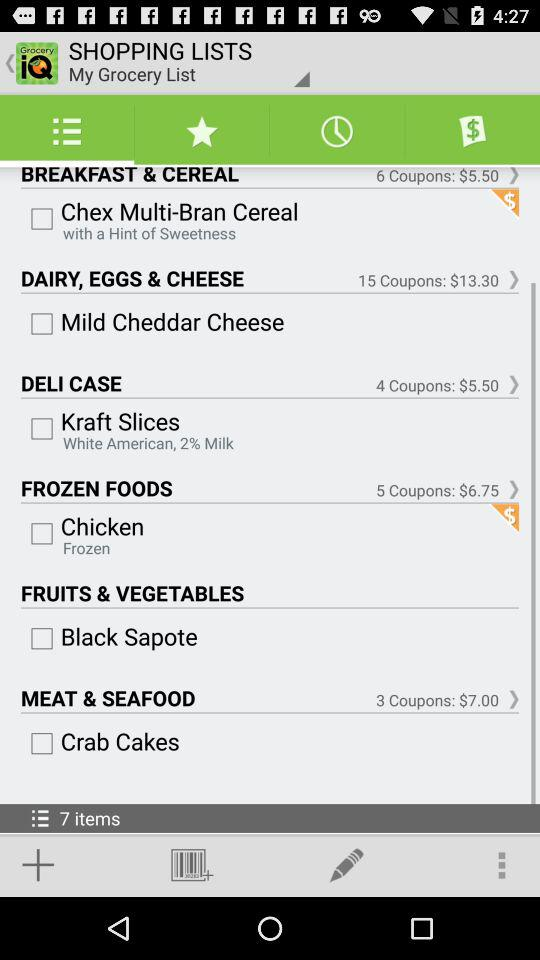How much do coupons for frozen foods cost? The coupons cost for frozen food is $6.75. 